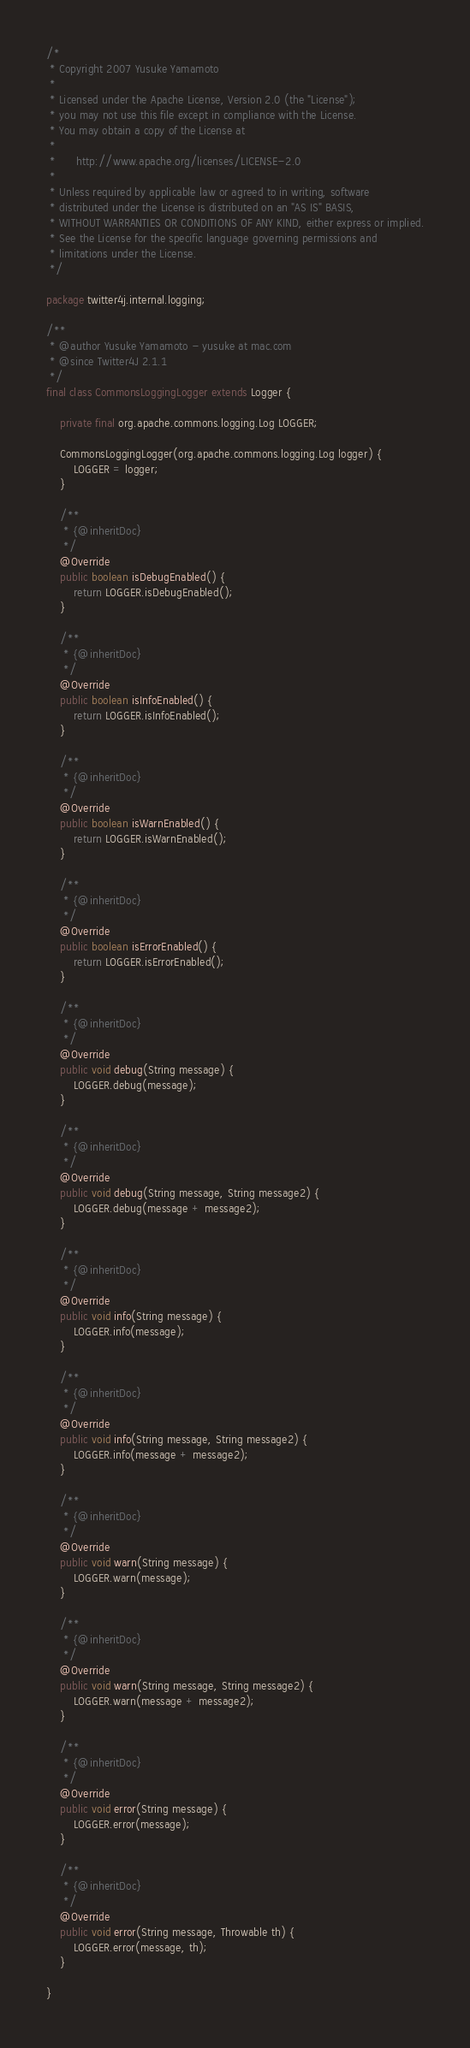<code> <loc_0><loc_0><loc_500><loc_500><_Java_>/*
 * Copyright 2007 Yusuke Yamamoto
 *
 * Licensed under the Apache License, Version 2.0 (the "License");
 * you may not use this file except in compliance with the License.
 * You may obtain a copy of the License at
 *
 *      http://www.apache.org/licenses/LICENSE-2.0
 *
 * Unless required by applicable law or agreed to in writing, software
 * distributed under the License is distributed on an "AS IS" BASIS,
 * WITHOUT WARRANTIES OR CONDITIONS OF ANY KIND, either express or implied.
 * See the License for the specific language governing permissions and
 * limitations under the License.
 */

package twitter4j.internal.logging;

/**
 * @author Yusuke Yamamoto - yusuke at mac.com
 * @since Twitter4J 2.1.1
 */
final class CommonsLoggingLogger extends Logger {

    private final org.apache.commons.logging.Log LOGGER;

    CommonsLoggingLogger(org.apache.commons.logging.Log logger) {
        LOGGER = logger;
    }

    /**
     * {@inheritDoc}
     */
    @Override
    public boolean isDebugEnabled() {
        return LOGGER.isDebugEnabled();
    }

    /**
     * {@inheritDoc}
     */
    @Override
    public boolean isInfoEnabled() {
        return LOGGER.isInfoEnabled();
    }

    /**
     * {@inheritDoc}
     */
    @Override
    public boolean isWarnEnabled() {
        return LOGGER.isWarnEnabled();
    }

    /**
     * {@inheritDoc}
     */
    @Override
    public boolean isErrorEnabled() {
        return LOGGER.isErrorEnabled();
    }

    /**
     * {@inheritDoc}
     */
    @Override
    public void debug(String message) {
        LOGGER.debug(message);
    }

    /**
     * {@inheritDoc}
     */
    @Override
    public void debug(String message, String message2) {
        LOGGER.debug(message + message2);
    }

    /**
     * {@inheritDoc}
     */
    @Override
    public void info(String message) {
        LOGGER.info(message);
    }

    /**
     * {@inheritDoc}
     */
    @Override
    public void info(String message, String message2) {
        LOGGER.info(message + message2);
    }

    /**
     * {@inheritDoc}
     */
    @Override
    public void warn(String message) {
        LOGGER.warn(message);
    }

    /**
     * {@inheritDoc}
     */
    @Override
    public void warn(String message, String message2) {
        LOGGER.warn(message + message2);
    }

    /**
     * {@inheritDoc}
     */
    @Override
    public void error(String message) {
        LOGGER.error(message);
    }

    /**
     * {@inheritDoc}
     */
    @Override
    public void error(String message, Throwable th) {
        LOGGER.error(message, th);
    }

}
</code> 